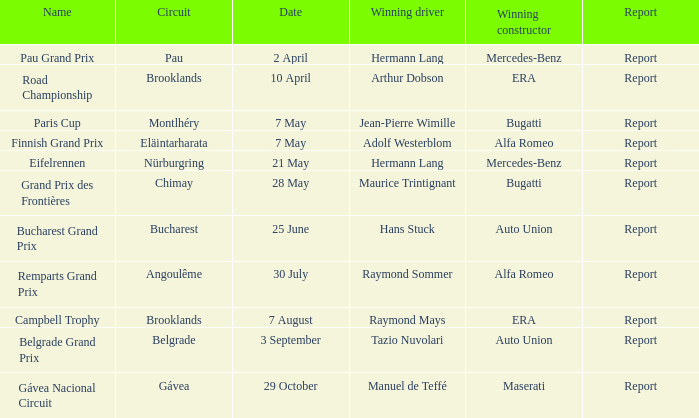Tell me the report for 30 july Report. 